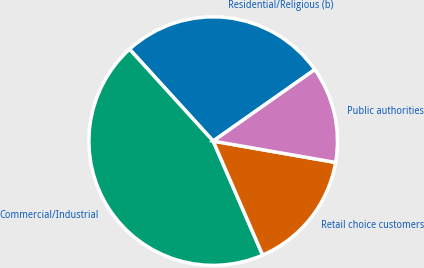Convert chart to OTSL. <chart><loc_0><loc_0><loc_500><loc_500><pie_chart><fcel>Residential/Religious (b)<fcel>Commercial/Industrial<fcel>Retail choice customers<fcel>Public authorities<nl><fcel>26.99%<fcel>44.77%<fcel>15.73%<fcel>12.51%<nl></chart> 